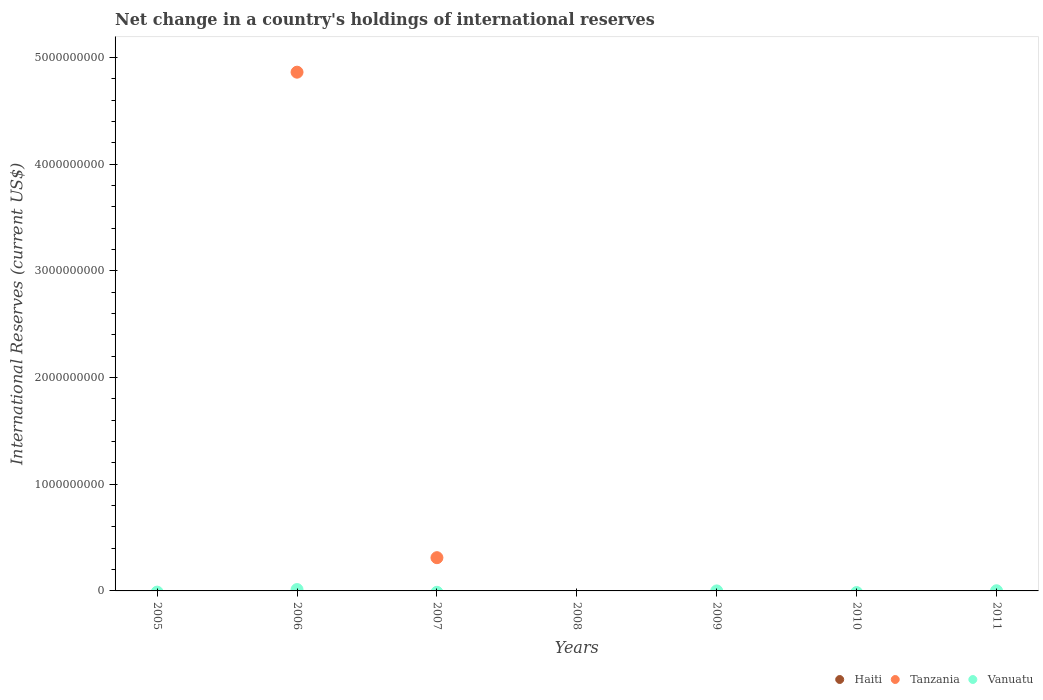Is the number of dotlines equal to the number of legend labels?
Give a very brief answer. No. What is the international reserves in Tanzania in 2005?
Offer a very short reply. 0. Across all years, what is the maximum international reserves in Vanuatu?
Offer a very short reply. 1.29e+07. What is the total international reserves in Tanzania in the graph?
Offer a very short reply. 5.17e+09. What is the difference between the international reserves in Haiti in 2005 and the international reserves in Vanuatu in 2007?
Offer a terse response. 0. What is the average international reserves in Haiti per year?
Ensure brevity in your answer.  0. What is the ratio of the international reserves in Vanuatu in 2009 to that in 2011?
Your response must be concise. 0.07. What is the difference between the highest and the second highest international reserves in Vanuatu?
Your response must be concise. 1.14e+07. What is the difference between the highest and the lowest international reserves in Vanuatu?
Make the answer very short. 1.29e+07. Is it the case that in every year, the sum of the international reserves in Vanuatu and international reserves in Tanzania  is greater than the international reserves in Haiti?
Your response must be concise. No. Does the international reserves in Vanuatu monotonically increase over the years?
Offer a terse response. No. How many years are there in the graph?
Offer a terse response. 7. Are the values on the major ticks of Y-axis written in scientific E-notation?
Provide a short and direct response. No. Does the graph contain any zero values?
Your response must be concise. Yes. Does the graph contain grids?
Your answer should be compact. No. How many legend labels are there?
Your answer should be compact. 3. How are the legend labels stacked?
Provide a short and direct response. Horizontal. What is the title of the graph?
Provide a short and direct response. Net change in a country's holdings of international reserves. Does "Chad" appear as one of the legend labels in the graph?
Give a very brief answer. No. What is the label or title of the Y-axis?
Your answer should be very brief. International Reserves (current US$). What is the International Reserves (current US$) in Haiti in 2006?
Ensure brevity in your answer.  0. What is the International Reserves (current US$) of Tanzania in 2006?
Your response must be concise. 4.86e+09. What is the International Reserves (current US$) of Vanuatu in 2006?
Give a very brief answer. 1.29e+07. What is the International Reserves (current US$) in Haiti in 2007?
Offer a very short reply. 0. What is the International Reserves (current US$) in Tanzania in 2007?
Keep it short and to the point. 3.12e+08. What is the International Reserves (current US$) of Vanuatu in 2007?
Your answer should be very brief. 0. What is the International Reserves (current US$) of Tanzania in 2008?
Give a very brief answer. 0. What is the International Reserves (current US$) in Vanuatu in 2009?
Offer a terse response. 1.01e+05. What is the International Reserves (current US$) of Haiti in 2010?
Keep it short and to the point. 0. What is the International Reserves (current US$) of Haiti in 2011?
Give a very brief answer. 0. What is the International Reserves (current US$) of Vanuatu in 2011?
Ensure brevity in your answer.  1.52e+06. Across all years, what is the maximum International Reserves (current US$) of Tanzania?
Your answer should be compact. 4.86e+09. Across all years, what is the maximum International Reserves (current US$) of Vanuatu?
Provide a short and direct response. 1.29e+07. Across all years, what is the minimum International Reserves (current US$) of Vanuatu?
Offer a terse response. 0. What is the total International Reserves (current US$) in Tanzania in the graph?
Your answer should be very brief. 5.17e+09. What is the total International Reserves (current US$) in Vanuatu in the graph?
Provide a succinct answer. 1.45e+07. What is the difference between the International Reserves (current US$) of Tanzania in 2006 and that in 2007?
Your answer should be compact. 4.55e+09. What is the difference between the International Reserves (current US$) in Vanuatu in 2006 and that in 2009?
Your answer should be very brief. 1.28e+07. What is the difference between the International Reserves (current US$) of Vanuatu in 2006 and that in 2011?
Your answer should be compact. 1.14e+07. What is the difference between the International Reserves (current US$) in Vanuatu in 2009 and that in 2011?
Ensure brevity in your answer.  -1.42e+06. What is the difference between the International Reserves (current US$) of Tanzania in 2006 and the International Reserves (current US$) of Vanuatu in 2009?
Offer a very short reply. 4.86e+09. What is the difference between the International Reserves (current US$) in Tanzania in 2006 and the International Reserves (current US$) in Vanuatu in 2011?
Offer a very short reply. 4.86e+09. What is the difference between the International Reserves (current US$) of Tanzania in 2007 and the International Reserves (current US$) of Vanuatu in 2009?
Your answer should be very brief. 3.12e+08. What is the difference between the International Reserves (current US$) of Tanzania in 2007 and the International Reserves (current US$) of Vanuatu in 2011?
Ensure brevity in your answer.  3.10e+08. What is the average International Reserves (current US$) of Haiti per year?
Make the answer very short. 0. What is the average International Reserves (current US$) in Tanzania per year?
Offer a terse response. 7.39e+08. What is the average International Reserves (current US$) of Vanuatu per year?
Offer a very short reply. 2.07e+06. In the year 2006, what is the difference between the International Reserves (current US$) in Tanzania and International Reserves (current US$) in Vanuatu?
Provide a succinct answer. 4.85e+09. What is the ratio of the International Reserves (current US$) of Tanzania in 2006 to that in 2007?
Your response must be concise. 15.6. What is the ratio of the International Reserves (current US$) of Vanuatu in 2006 to that in 2009?
Keep it short and to the point. 127.49. What is the ratio of the International Reserves (current US$) in Vanuatu in 2006 to that in 2011?
Offer a terse response. 8.48. What is the ratio of the International Reserves (current US$) in Vanuatu in 2009 to that in 2011?
Your response must be concise. 0.07. What is the difference between the highest and the second highest International Reserves (current US$) of Vanuatu?
Give a very brief answer. 1.14e+07. What is the difference between the highest and the lowest International Reserves (current US$) of Tanzania?
Your answer should be compact. 4.86e+09. What is the difference between the highest and the lowest International Reserves (current US$) in Vanuatu?
Keep it short and to the point. 1.29e+07. 